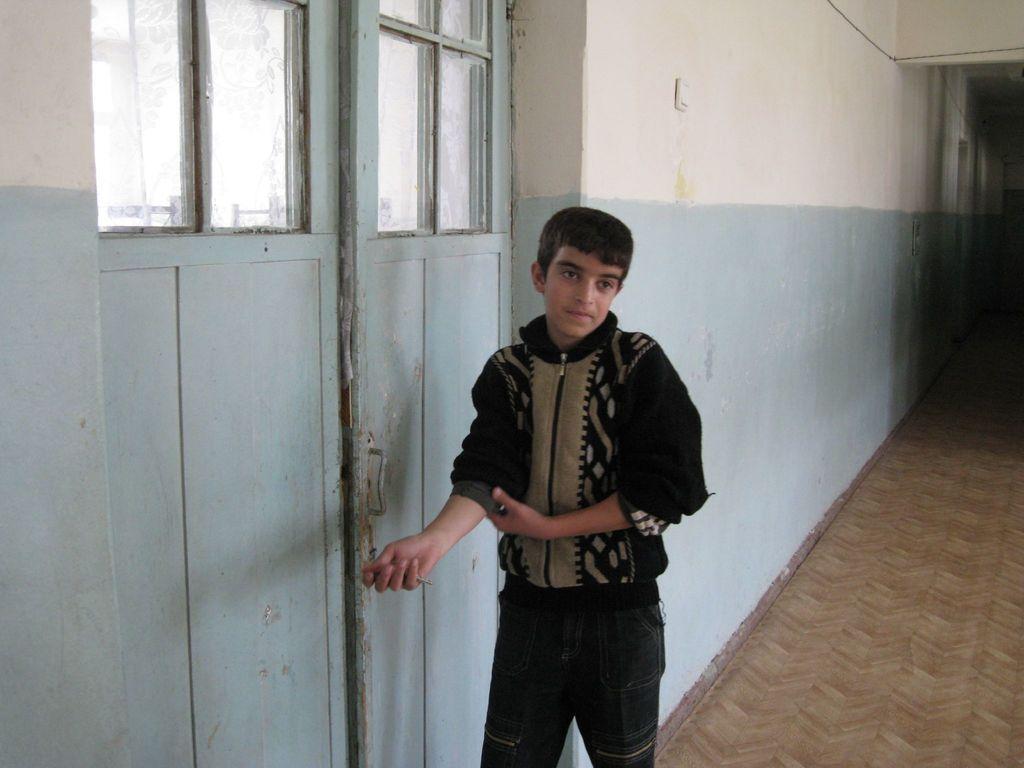Please provide a concise description of this image. In this image we can see a boy. In the background, we can see a wall and a door. We can see a carpet in the right bottom of the image. 